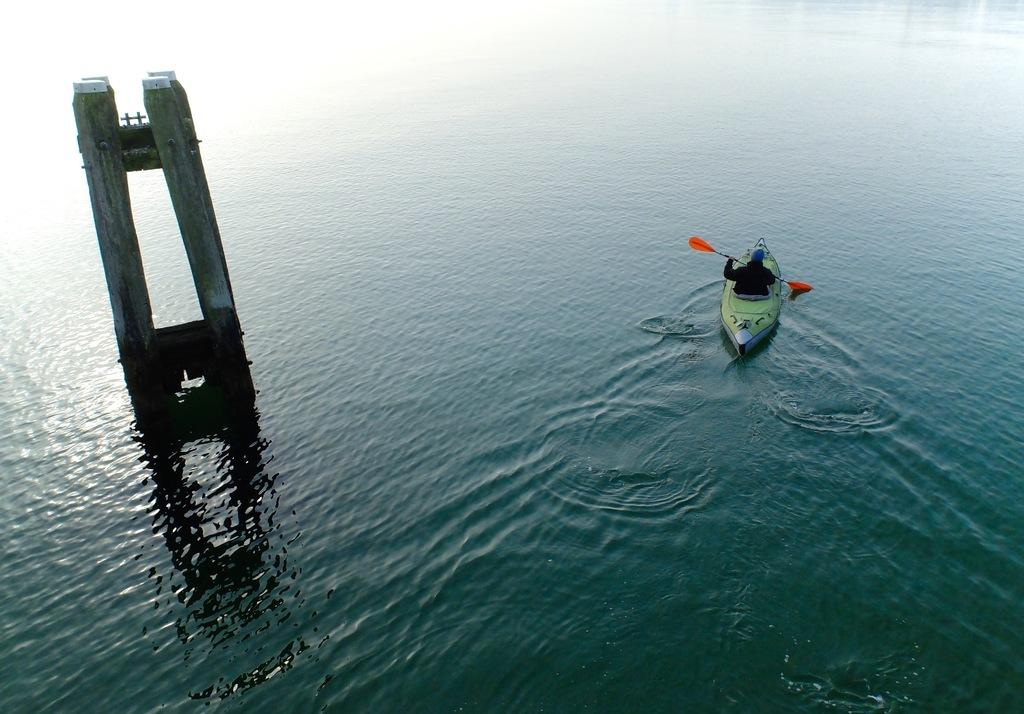What is the person in the image doing? The person in the image is rowing a boat. Where is the boat located? The boat is in the middle of a river. What can be seen on the left side of the image? There are 2 big pillars on the left side of the image. What is the result of adding 2 and 3 in the image? There is no addition or mathematical operation present in the image; it features a person rowing a boat in a river with 2 big pillars on the left side. 